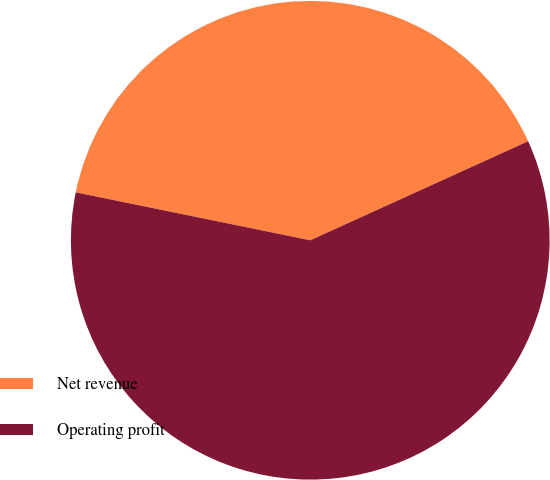Convert chart. <chart><loc_0><loc_0><loc_500><loc_500><pie_chart><fcel>Net revenue<fcel>Operating profit<nl><fcel>40.0%<fcel>60.0%<nl></chart> 